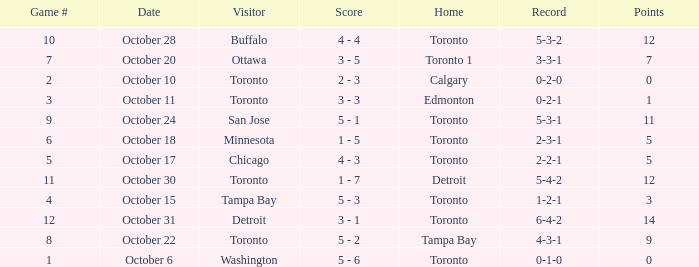What is the score when the record was 5-4-2? 1 - 7. 